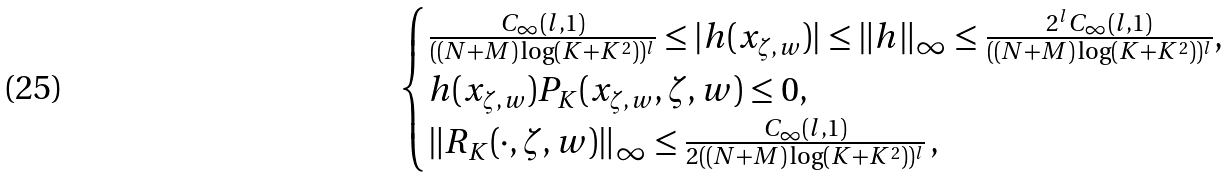<formula> <loc_0><loc_0><loc_500><loc_500>\begin{cases} \frac { C _ { \infty } ( l , 1 ) } { ( ( N + M ) \log ( K + K ^ { 2 } ) ) ^ { l } } \leq | h ( x _ { \zeta , w } ) | \leq \| h \| _ { \infty } \leq \frac { 2 ^ { l } C _ { \infty } ( l , 1 ) } { ( ( N + M ) \log ( K + K ^ { 2 } ) ) ^ { l } } , \\ h ( x _ { \zeta , w } ) P _ { K } ( x _ { \zeta , w } , \zeta , w ) \leq 0 , \\ \left \| R _ { K } ( \cdot , \zeta , w ) \right \| _ { \infty } \leq \frac { C _ { \infty } ( l , 1 ) } { 2 ( ( N + M ) \log ( K + K ^ { 2 } ) ) ^ { l } } \, , \end{cases}</formula> 